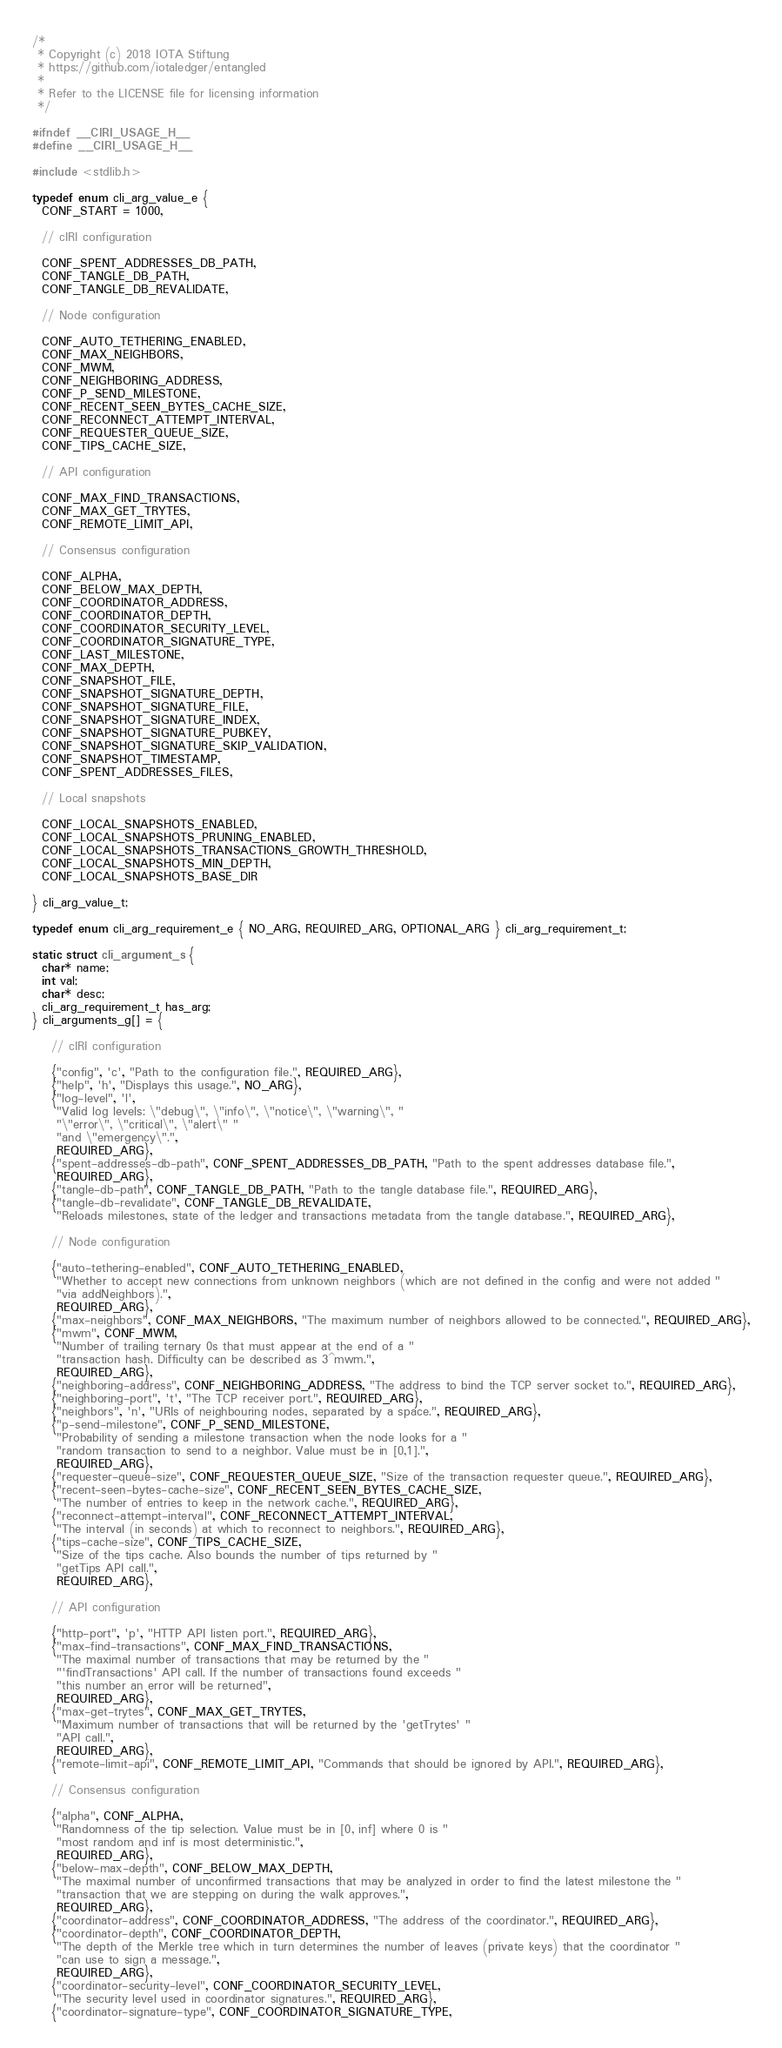<code> <loc_0><loc_0><loc_500><loc_500><_C_>/*
 * Copyright (c) 2018 IOTA Stiftung
 * https://github.com/iotaledger/entangled
 *
 * Refer to the LICENSE file for licensing information
 */

#ifndef __CIRI_USAGE_H__
#define __CIRI_USAGE_H__

#include <stdlib.h>

typedef enum cli_arg_value_e {
  CONF_START = 1000,

  // cIRI configuration

  CONF_SPENT_ADDRESSES_DB_PATH,
  CONF_TANGLE_DB_PATH,
  CONF_TANGLE_DB_REVALIDATE,

  // Node configuration

  CONF_AUTO_TETHERING_ENABLED,
  CONF_MAX_NEIGHBORS,
  CONF_MWM,
  CONF_NEIGHBORING_ADDRESS,
  CONF_P_SEND_MILESTONE,
  CONF_RECENT_SEEN_BYTES_CACHE_SIZE,
  CONF_RECONNECT_ATTEMPT_INTERVAL,
  CONF_REQUESTER_QUEUE_SIZE,
  CONF_TIPS_CACHE_SIZE,

  // API configuration

  CONF_MAX_FIND_TRANSACTIONS,
  CONF_MAX_GET_TRYTES,
  CONF_REMOTE_LIMIT_API,

  // Consensus configuration

  CONF_ALPHA,
  CONF_BELOW_MAX_DEPTH,
  CONF_COORDINATOR_ADDRESS,
  CONF_COORDINATOR_DEPTH,
  CONF_COORDINATOR_SECURITY_LEVEL,
  CONF_COORDINATOR_SIGNATURE_TYPE,
  CONF_LAST_MILESTONE,
  CONF_MAX_DEPTH,
  CONF_SNAPSHOT_FILE,
  CONF_SNAPSHOT_SIGNATURE_DEPTH,
  CONF_SNAPSHOT_SIGNATURE_FILE,
  CONF_SNAPSHOT_SIGNATURE_INDEX,
  CONF_SNAPSHOT_SIGNATURE_PUBKEY,
  CONF_SNAPSHOT_SIGNATURE_SKIP_VALIDATION,
  CONF_SNAPSHOT_TIMESTAMP,
  CONF_SPENT_ADDRESSES_FILES,

  // Local snapshots

  CONF_LOCAL_SNAPSHOTS_ENABLED,
  CONF_LOCAL_SNAPSHOTS_PRUNING_ENABLED,
  CONF_LOCAL_SNAPSHOTS_TRANSACTIONS_GROWTH_THRESHOLD,
  CONF_LOCAL_SNAPSHOTS_MIN_DEPTH,
  CONF_LOCAL_SNAPSHOTS_BASE_DIR

} cli_arg_value_t;

typedef enum cli_arg_requirement_e { NO_ARG, REQUIRED_ARG, OPTIONAL_ARG } cli_arg_requirement_t;

static struct cli_argument_s {
  char* name;
  int val;
  char* desc;
  cli_arg_requirement_t has_arg;
} cli_arguments_g[] = {

    // cIRI configuration

    {"config", 'c', "Path to the configuration file.", REQUIRED_ARG},
    {"help", 'h', "Displays this usage.", NO_ARG},
    {"log-level", 'l',
     "Valid log levels: \"debug\", \"info\", \"notice\", \"warning\", "
     "\"error\", \"critical\", \"alert\" "
     "and \"emergency\".",
     REQUIRED_ARG},
    {"spent-addresses-db-path", CONF_SPENT_ADDRESSES_DB_PATH, "Path to the spent addresses database file.",
     REQUIRED_ARG},
    {"tangle-db-path", CONF_TANGLE_DB_PATH, "Path to the tangle database file.", REQUIRED_ARG},
    {"tangle-db-revalidate", CONF_TANGLE_DB_REVALIDATE,
     "Reloads milestones, state of the ledger and transactions metadata from the tangle database.", REQUIRED_ARG},

    // Node configuration

    {"auto-tethering-enabled", CONF_AUTO_TETHERING_ENABLED,
     "Whether to accept new connections from unknown neighbors (which are not defined in the config and were not added "
     "via addNeighbors).",
     REQUIRED_ARG},
    {"max-neighbors", CONF_MAX_NEIGHBORS, "The maximum number of neighbors allowed to be connected.", REQUIRED_ARG},
    {"mwm", CONF_MWM,
     "Number of trailing ternary 0s that must appear at the end of a "
     "transaction hash. Difficulty can be described as 3^mwm.",
     REQUIRED_ARG},
    {"neighboring-address", CONF_NEIGHBORING_ADDRESS, "The address to bind the TCP server socket to.", REQUIRED_ARG},
    {"neighboring-port", 't', "The TCP receiver port.", REQUIRED_ARG},
    {"neighbors", 'n', "URIs of neighbouring nodes, separated by a space.", REQUIRED_ARG},
    {"p-send-milestone", CONF_P_SEND_MILESTONE,
     "Probability of sending a milestone transaction when the node looks for a "
     "random transaction to send to a neighbor. Value must be in [0,1].",
     REQUIRED_ARG},
    {"requester-queue-size", CONF_REQUESTER_QUEUE_SIZE, "Size of the transaction requester queue.", REQUIRED_ARG},
    {"recent-seen-bytes-cache-size", CONF_RECENT_SEEN_BYTES_CACHE_SIZE,
     "The number of entries to keep in the network cache.", REQUIRED_ARG},
    {"reconnect-attempt-interval", CONF_RECONNECT_ATTEMPT_INTERVAL,
     "The interval (in seconds) at which to reconnect to neighbors.", REQUIRED_ARG},
    {"tips-cache-size", CONF_TIPS_CACHE_SIZE,
     "Size of the tips cache. Also bounds the number of tips returned by "
     "getTips API call.",
     REQUIRED_ARG},

    // API configuration

    {"http-port", 'p', "HTTP API listen port.", REQUIRED_ARG},
    {"max-find-transactions", CONF_MAX_FIND_TRANSACTIONS,
     "The maximal number of transactions that may be returned by the "
     "'findTransactions' API call. If the number of transactions found exceeds "
     "this number an error will be returned",
     REQUIRED_ARG},
    {"max-get-trytes", CONF_MAX_GET_TRYTES,
     "Maximum number of transactions that will be returned by the 'getTrytes' "
     "API call.",
     REQUIRED_ARG},
    {"remote-limit-api", CONF_REMOTE_LIMIT_API, "Commands that should be ignored by API.", REQUIRED_ARG},

    // Consensus configuration

    {"alpha", CONF_ALPHA,
     "Randomness of the tip selection. Value must be in [0, inf] where 0 is "
     "most random and inf is most deterministic.",
     REQUIRED_ARG},
    {"below-max-depth", CONF_BELOW_MAX_DEPTH,
     "The maximal number of unconfirmed transactions that may be analyzed in order to find the latest milestone the "
     "transaction that we are stepping on during the walk approves.",
     REQUIRED_ARG},
    {"coordinator-address", CONF_COORDINATOR_ADDRESS, "The address of the coordinator.", REQUIRED_ARG},
    {"coordinator-depth", CONF_COORDINATOR_DEPTH,
     "The depth of the Merkle tree which in turn determines the number of leaves (private keys) that the coordinator "
     "can use to sign a message.",
     REQUIRED_ARG},
    {"coordinator-security-level", CONF_COORDINATOR_SECURITY_LEVEL,
     "The security level used in coordinator signatures.", REQUIRED_ARG},
    {"coordinator-signature-type", CONF_COORDINATOR_SIGNATURE_TYPE,</code> 